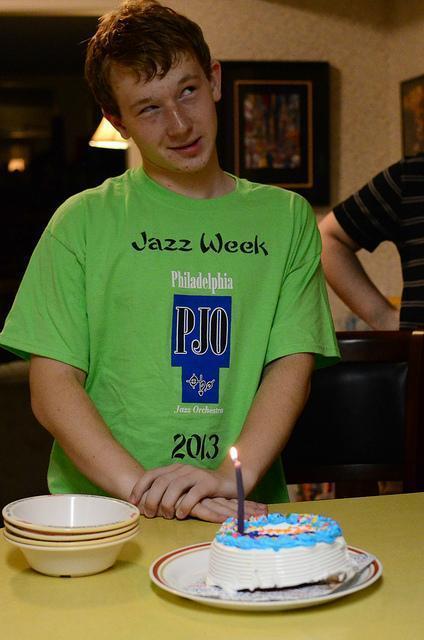How many bowls are shown?
Give a very brief answer. 4. How many bowls are in the photo?
Give a very brief answer. 2. How many people can be seen?
Give a very brief answer. 2. How many chairs are there?
Give a very brief answer. 2. 